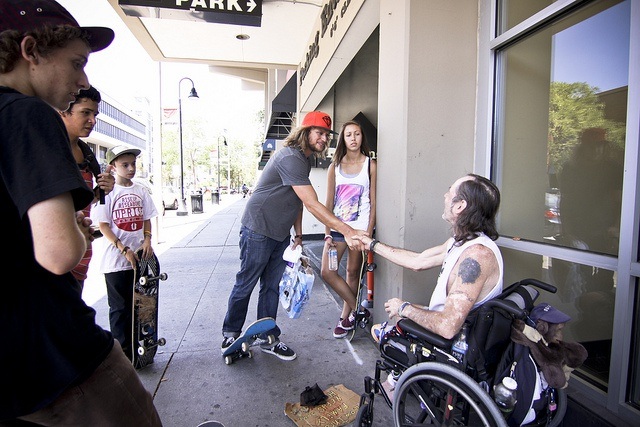Describe the objects in this image and their specific colors. I can see people in black, brown, and maroon tones, people in black and gray tones, people in black, lightgray, pink, and darkgray tones, people in black, lavender, darkgray, and gray tones, and people in black, lavender, gray, and lightpink tones in this image. 